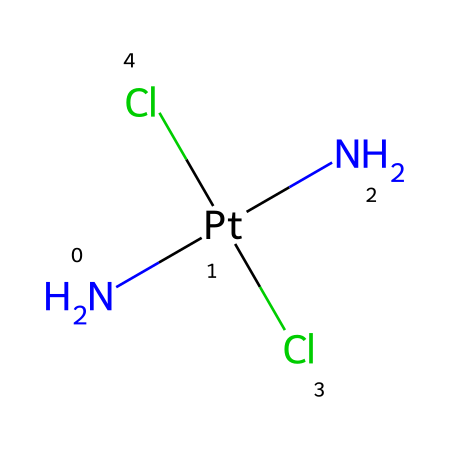What is the central metal atom in cisplatin? The central metal atom can be identified as the one that is bonded to other ligands in the chemical structure. In this case, it is platinum, which is denoted by "Pt" in the SMILES representation.
Answer: platinum How many chloride ligands are present in cisplatin? The structure reveals two chloride atoms connected to the central platinum atom, indicated by the "Cl" notation in the SMILES.
Answer: 2 What is the coordination number of the central metal atom in cisplatin? The coordination number is determined by the number of ligands directly bonded to the central atom. Here, platinum is bonded to two chlorides and two amines, totaling four ligands.
Answer: 4 Which functional groups are present in cisplatin? The presence of amine (indicated by "N") and chloride (indicated by "Cl") groups can be seen in the structure. Amine groups are characterized by nitrogen atoms bonded to hydrogen, while chlorides are halogen groups.
Answer: amine and chloride What type of chemical bonds are primarily present in cisplatin? The structure displays coordinate covalent bonds between the platinum atom and the ligands (ammonia and chloride ions). These involve sharing of electron pairs between the metal and ligands.
Answer: coordinate covalent In cisplatin, how many nitrogen atoms are part of the structure? The SMILES notation indicates two nitrogen atoms are present in the structure, specifically listed before the platinum in the formula.
Answer: 2 What is the geometry around the platinum atom in cisplatin? The arrangement of the ligands around the platinum atom is square planar due to the coordination number of 4 and the nature of the ligands.
Answer: square planar 